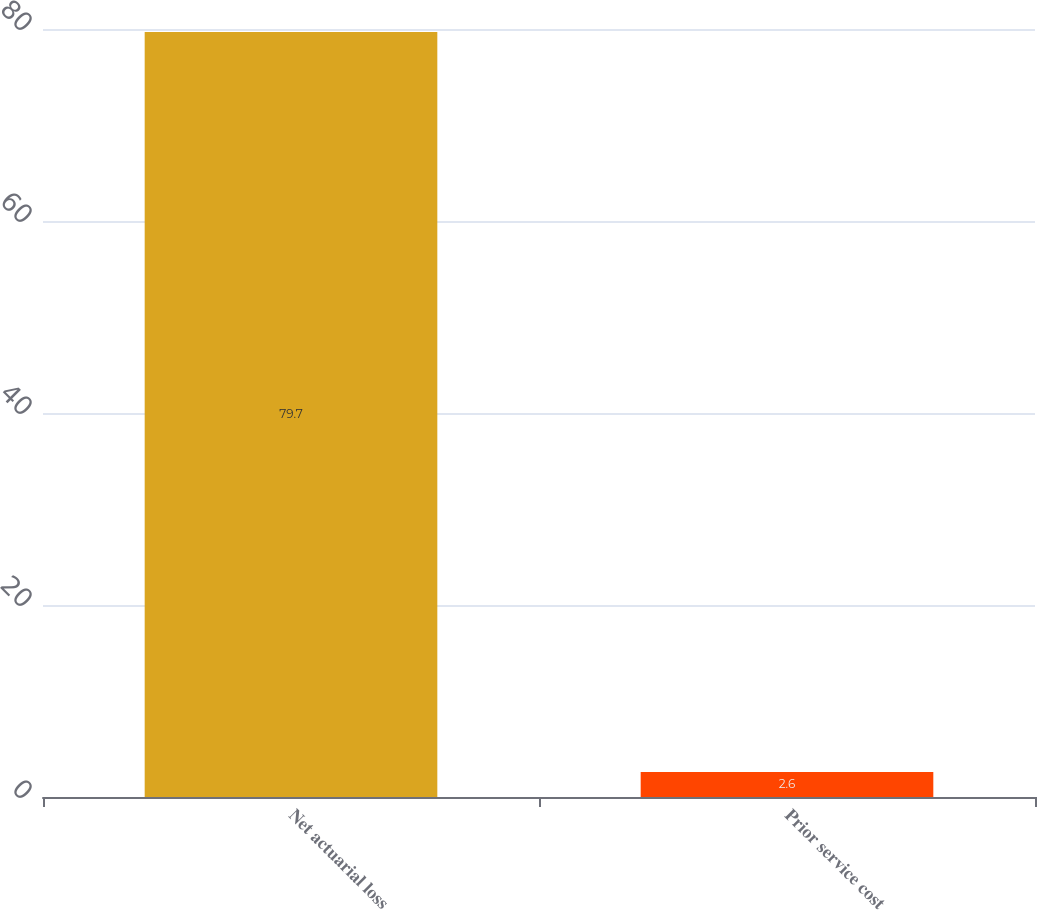Convert chart. <chart><loc_0><loc_0><loc_500><loc_500><bar_chart><fcel>Net actuarial loss<fcel>Prior service cost<nl><fcel>79.7<fcel>2.6<nl></chart> 